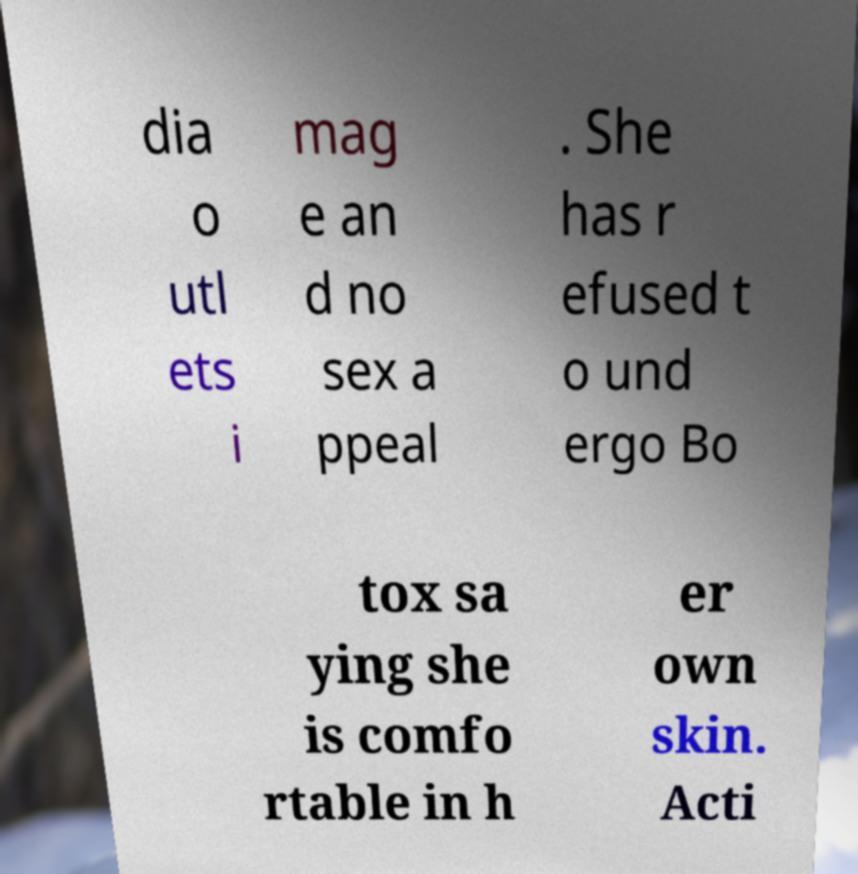Can you read and provide the text displayed in the image?This photo seems to have some interesting text. Can you extract and type it out for me? dia o utl ets i mag e an d no sex a ppeal . She has r efused t o und ergo Bo tox sa ying she is comfo rtable in h er own skin. Acti 